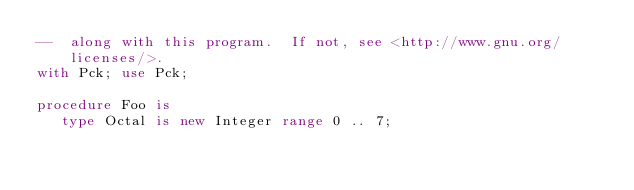<code> <loc_0><loc_0><loc_500><loc_500><_Ada_>--  along with this program.  If not, see <http://www.gnu.org/licenses/>.
with Pck; use Pck;

procedure Foo is
   type Octal is new Integer range 0 .. 7;</code> 